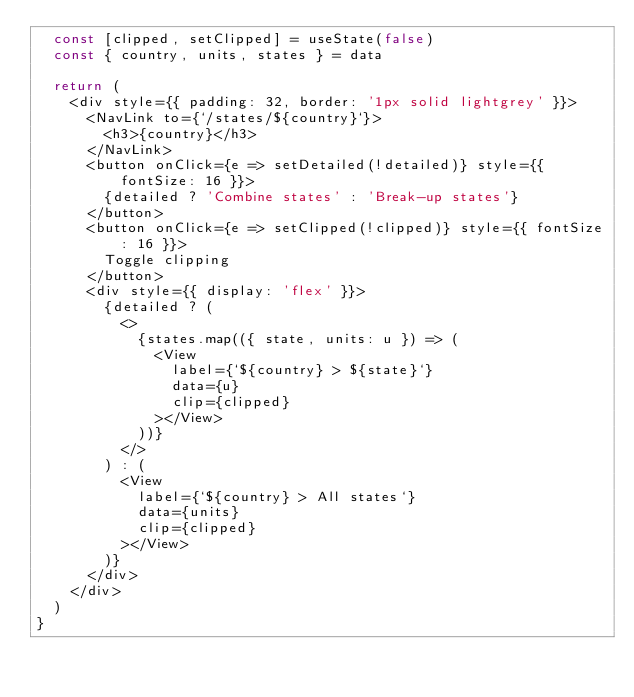Convert code to text. <code><loc_0><loc_0><loc_500><loc_500><_JavaScript_>  const [clipped, setClipped] = useState(false)
  const { country, units, states } = data

  return (
    <div style={{ padding: 32, border: '1px solid lightgrey' }}>
      <NavLink to={`/states/${country}`}>
        <h3>{country}</h3>
      </NavLink>
      <button onClick={e => setDetailed(!detailed)} style={{ fontSize: 16 }}>
        {detailed ? 'Combine states' : 'Break-up states'}
      </button>
      <button onClick={e => setClipped(!clipped)} style={{ fontSize: 16 }}>
        Toggle clipping
      </button>
      <div style={{ display: 'flex' }}>
        {detailed ? (
          <>
            {states.map(({ state, units: u }) => (
              <View
                label={`${country} > ${state}`}
                data={u}
                clip={clipped}
              ></View>
            ))}
          </>
        ) : (
          <View
            label={`${country} > All states`}
            data={units}
            clip={clipped}
          ></View>
        )}
      </div>
    </div>
  )
}
</code> 